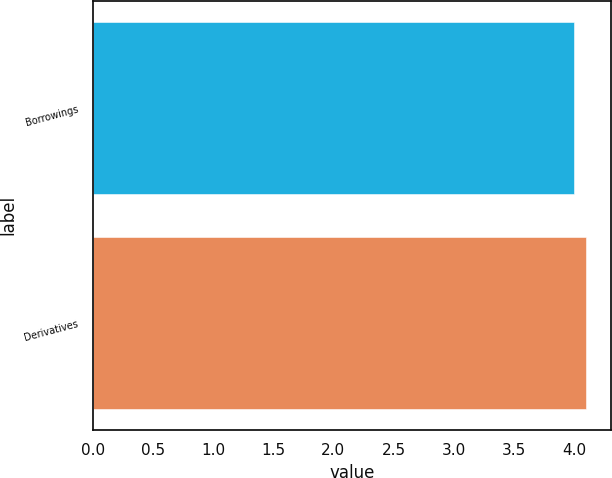Convert chart. <chart><loc_0><loc_0><loc_500><loc_500><bar_chart><fcel>Borrowings<fcel>Derivatives<nl><fcel>4<fcel>4.1<nl></chart> 